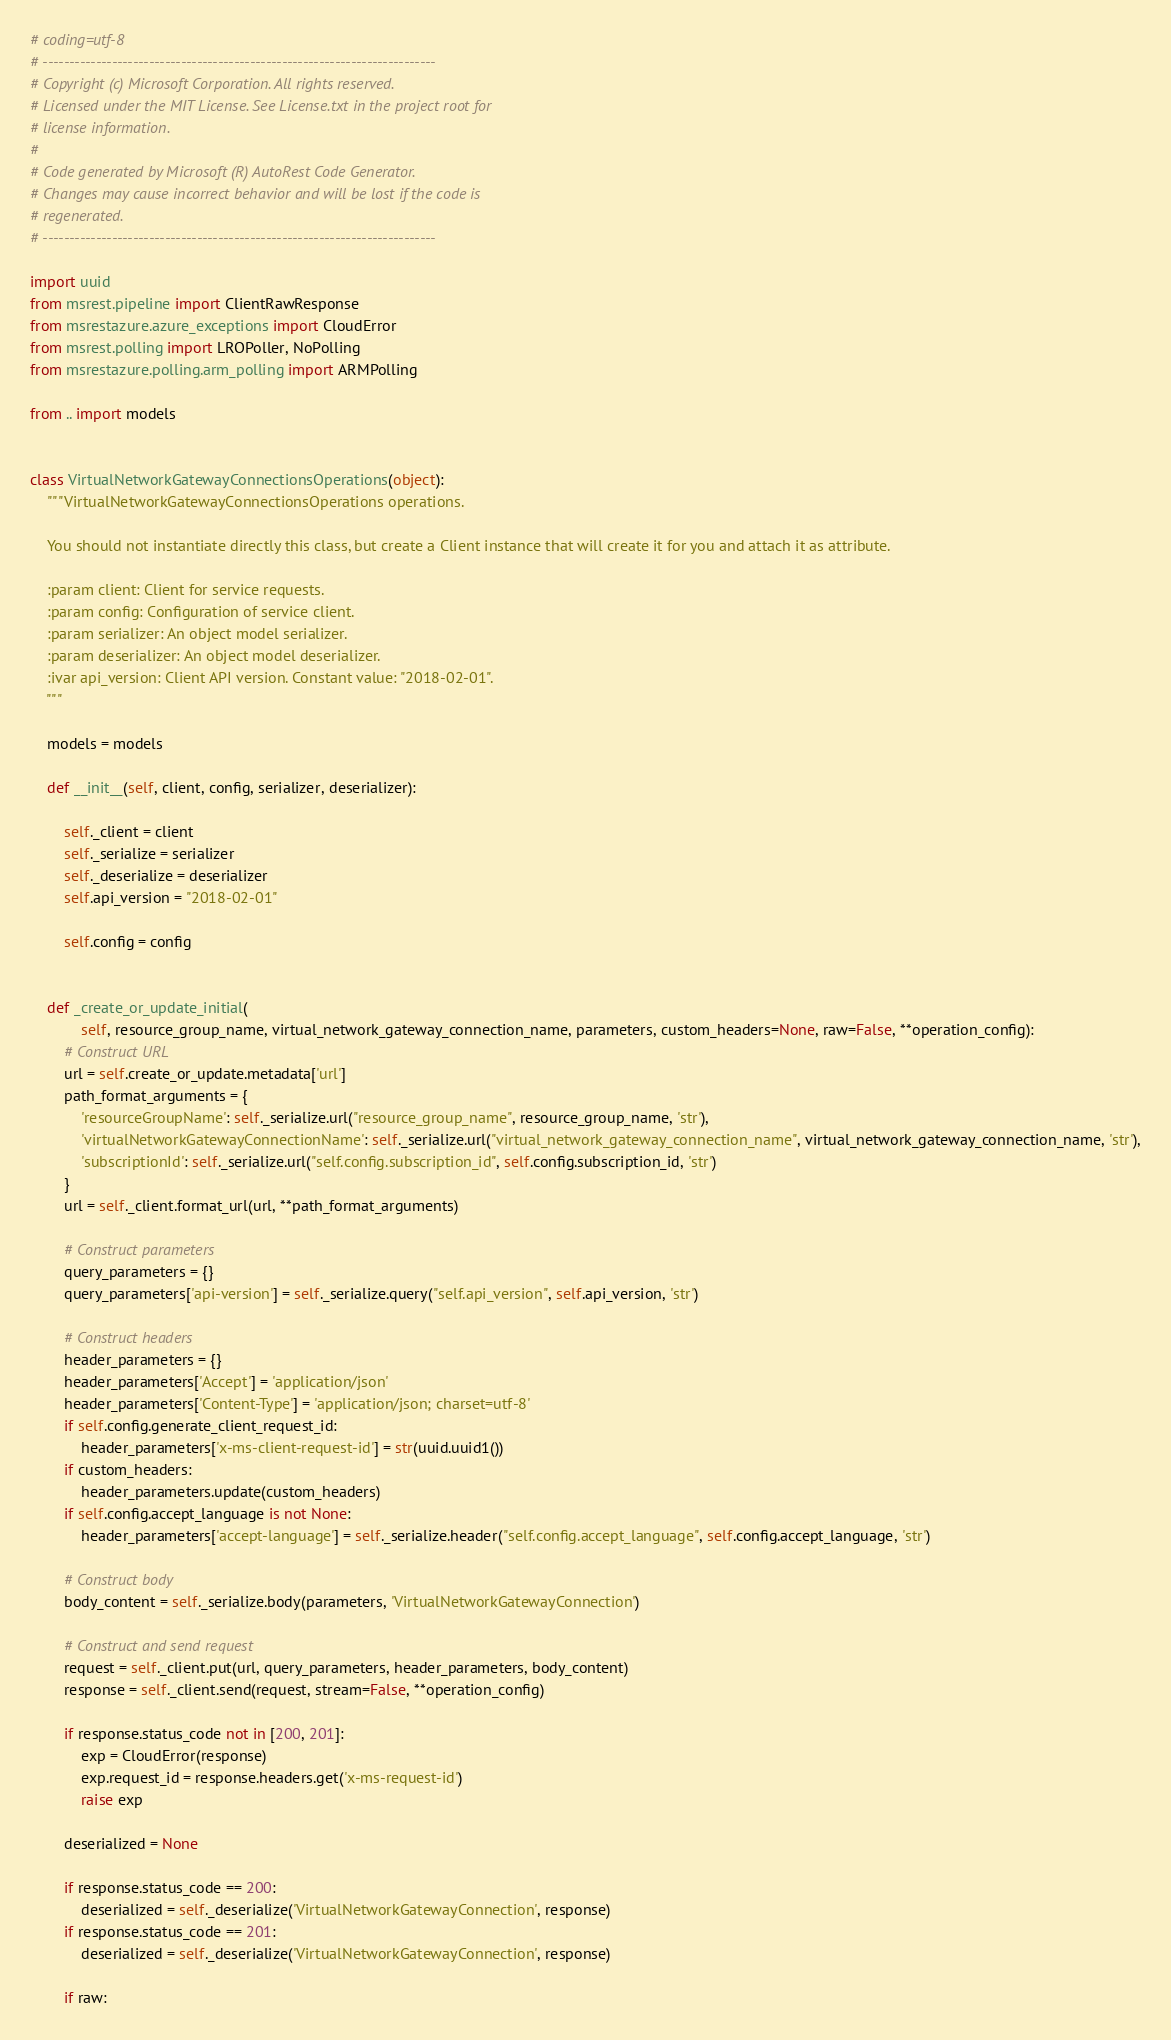<code> <loc_0><loc_0><loc_500><loc_500><_Python_># coding=utf-8
# --------------------------------------------------------------------------
# Copyright (c) Microsoft Corporation. All rights reserved.
# Licensed under the MIT License. See License.txt in the project root for
# license information.
#
# Code generated by Microsoft (R) AutoRest Code Generator.
# Changes may cause incorrect behavior and will be lost if the code is
# regenerated.
# --------------------------------------------------------------------------

import uuid
from msrest.pipeline import ClientRawResponse
from msrestazure.azure_exceptions import CloudError
from msrest.polling import LROPoller, NoPolling
from msrestazure.polling.arm_polling import ARMPolling

from .. import models


class VirtualNetworkGatewayConnectionsOperations(object):
    """VirtualNetworkGatewayConnectionsOperations operations.

    You should not instantiate directly this class, but create a Client instance that will create it for you and attach it as attribute.

    :param client: Client for service requests.
    :param config: Configuration of service client.
    :param serializer: An object model serializer.
    :param deserializer: An object model deserializer.
    :ivar api_version: Client API version. Constant value: "2018-02-01".
    """

    models = models

    def __init__(self, client, config, serializer, deserializer):

        self._client = client
        self._serialize = serializer
        self._deserialize = deserializer
        self.api_version = "2018-02-01"

        self.config = config


    def _create_or_update_initial(
            self, resource_group_name, virtual_network_gateway_connection_name, parameters, custom_headers=None, raw=False, **operation_config):
        # Construct URL
        url = self.create_or_update.metadata['url']
        path_format_arguments = {
            'resourceGroupName': self._serialize.url("resource_group_name", resource_group_name, 'str'),
            'virtualNetworkGatewayConnectionName': self._serialize.url("virtual_network_gateway_connection_name", virtual_network_gateway_connection_name, 'str'),
            'subscriptionId': self._serialize.url("self.config.subscription_id", self.config.subscription_id, 'str')
        }
        url = self._client.format_url(url, **path_format_arguments)

        # Construct parameters
        query_parameters = {}
        query_parameters['api-version'] = self._serialize.query("self.api_version", self.api_version, 'str')

        # Construct headers
        header_parameters = {}
        header_parameters['Accept'] = 'application/json'
        header_parameters['Content-Type'] = 'application/json; charset=utf-8'
        if self.config.generate_client_request_id:
            header_parameters['x-ms-client-request-id'] = str(uuid.uuid1())
        if custom_headers:
            header_parameters.update(custom_headers)
        if self.config.accept_language is not None:
            header_parameters['accept-language'] = self._serialize.header("self.config.accept_language", self.config.accept_language, 'str')

        # Construct body
        body_content = self._serialize.body(parameters, 'VirtualNetworkGatewayConnection')

        # Construct and send request
        request = self._client.put(url, query_parameters, header_parameters, body_content)
        response = self._client.send(request, stream=False, **operation_config)

        if response.status_code not in [200, 201]:
            exp = CloudError(response)
            exp.request_id = response.headers.get('x-ms-request-id')
            raise exp

        deserialized = None

        if response.status_code == 200:
            deserialized = self._deserialize('VirtualNetworkGatewayConnection', response)
        if response.status_code == 201:
            deserialized = self._deserialize('VirtualNetworkGatewayConnection', response)

        if raw:</code> 